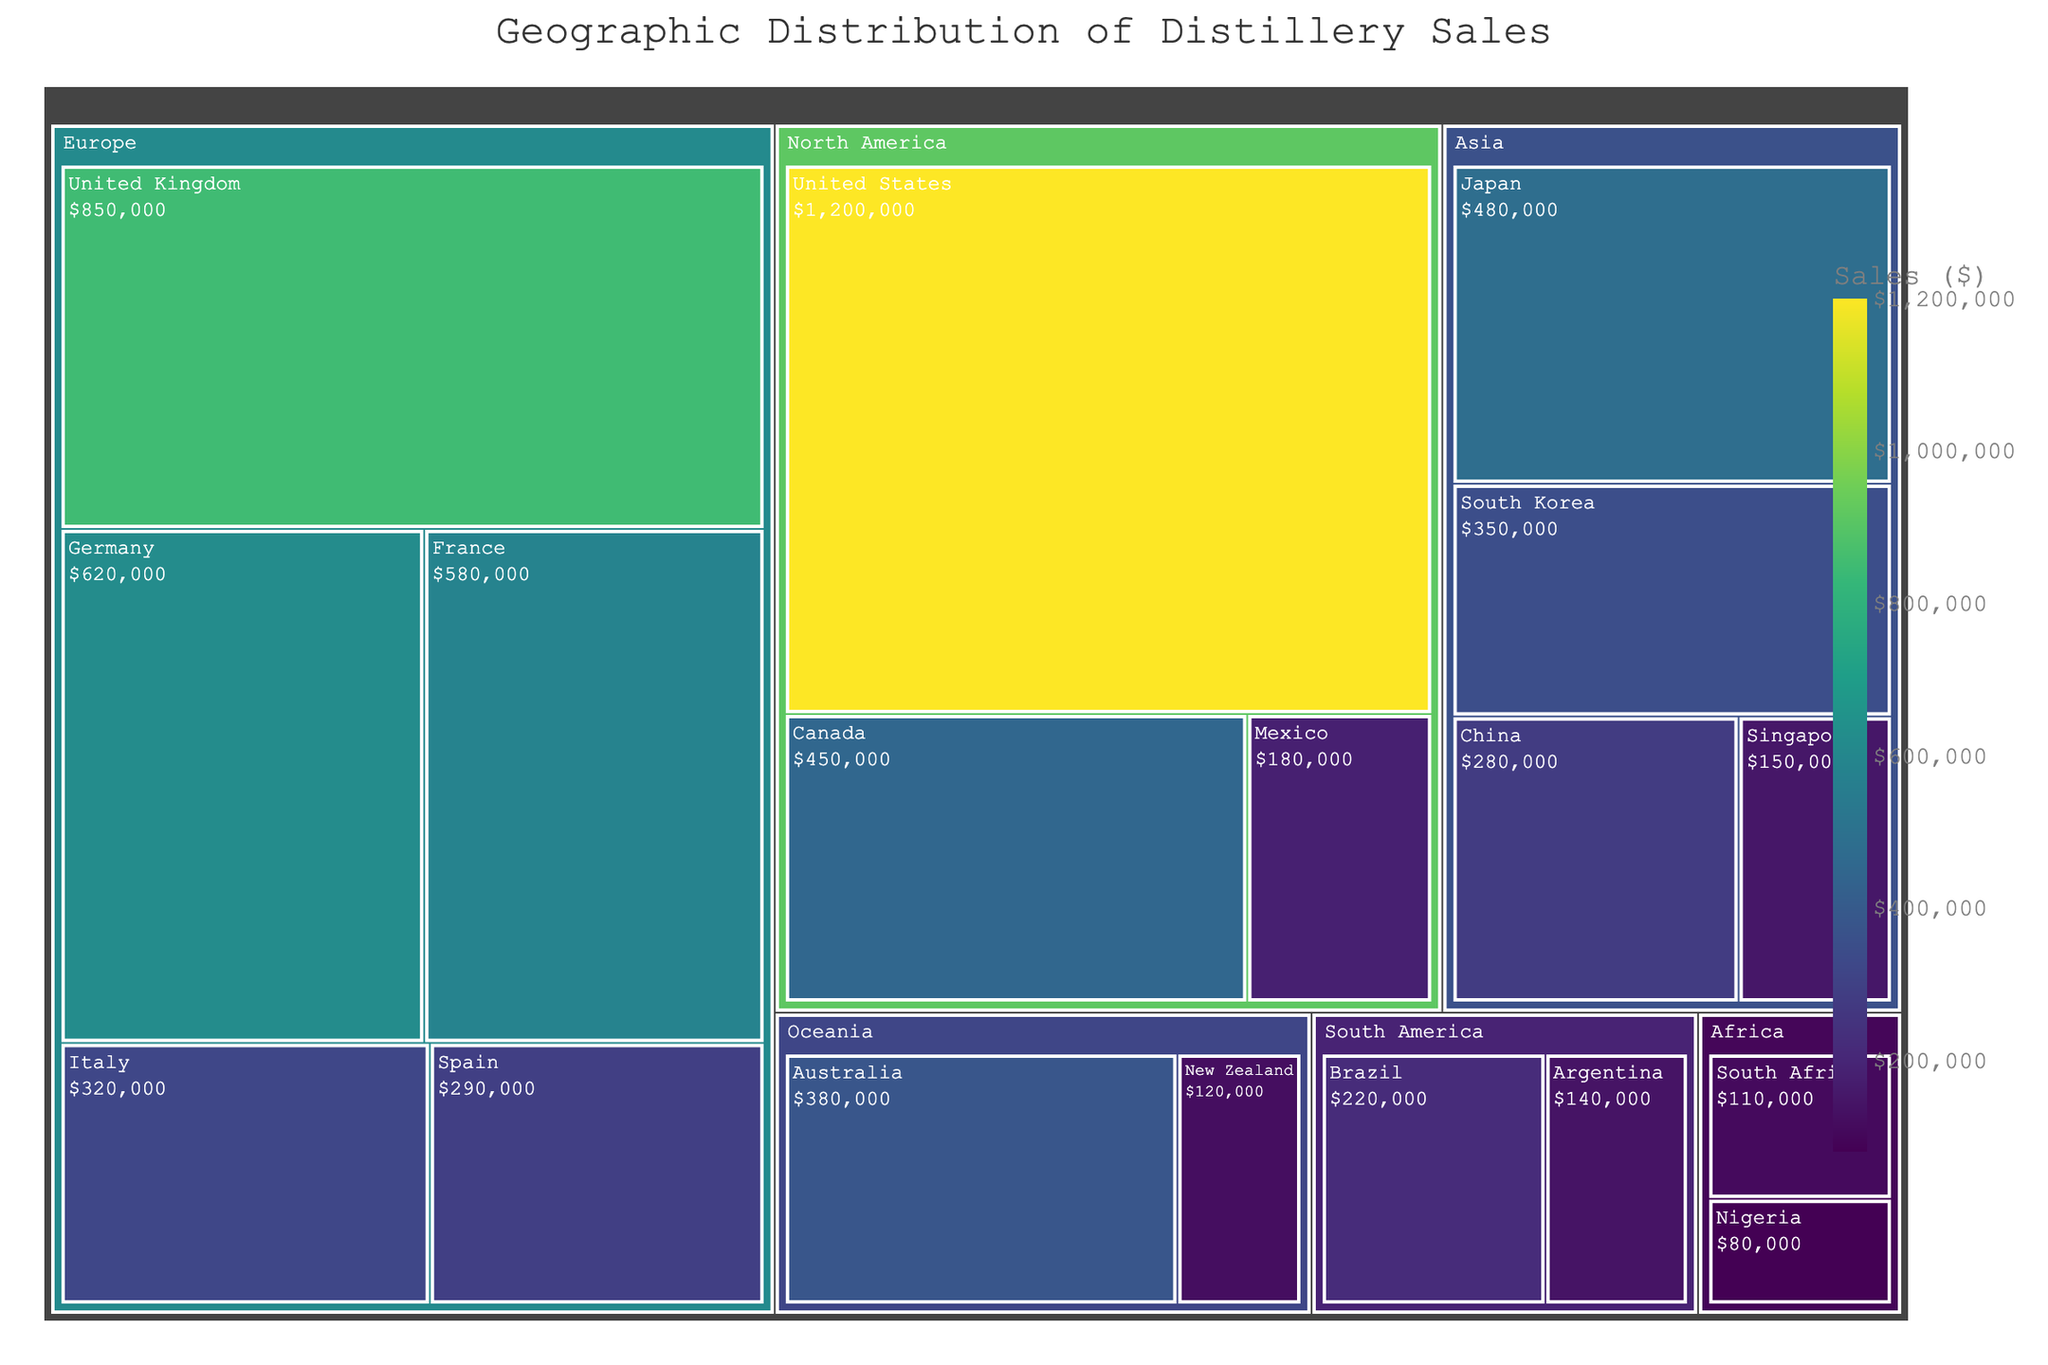What is the title of the treemap? The title of the treemap is usually found at the top of the figure and provides a concise description of what the figure represents.
Answer: Geographic Distribution of Distillery Sales Which region has the highest total sales? To determine the region with the highest total sales, add up sales values for each region and compare. The North America region has sales of $1,200,000 + $450,000 + $180,000 = $1,830,000. Europe has sales of $850,000 + $620,000 + $580,000 + $320,000 + $290,000 = $2,660,000. Asia has sales of $480,000 + $350,000 + $280,000 + $150,000 = $1,260,000. Oceania has $380,000 + $120,000 = $500,000. South America has $220,000 + $140,000 = $360,000. Africa has $110,000 + $80,000 = $190,000. Thus, Europe has the highest total sales.
Answer: Europe Which country in North America contributes the most to the region's total sales? Look at the sales values for United States, Canada, and Mexico in the North America region and identify the highest. The sales values are: United States ($1,200,000), Canada ($450,000), Mexico ($180,000). The United States has the highest sales.
Answer: United States How do the sales of Japan and South Korea compare? Compare the sales values for Japan and South Korea in the Asia region. Japan has $480,000 in sales, while South Korea has $350,000 in sales.
Answer: Japan has higher sales than South Korea What's the difference in sales between the United Kingdom and Germany? Subtract Germany's sales value from the United Kingdom's sales value. United Kingdom: $850,000; Germany: $620,000. The difference is $850,000 - $620,000 = $230,000.
Answer: $230,000 Which country in Africa has higher sales, and by how much? Compare the sales values for South Africa and Nigeria in the Africa region. South Africa has $110,000 in sales, and Nigeria has $80,000. The difference is $110,000 - $80,000 = $30,000.
Answer: South Africa by $30,000 What is the total sales for the Asia region? Add the sales values for Japan, South Korea, China, and Singapore in the Asia region. $480,000 + $350,000 + $280,000 + $150,000 = $1,260,000.
Answer: $1,260,000 Which region has the least total sales? Summing the sales values of each region and comparing them, Africa has the least sales with $110,000 (South Africa) + $80,000 (Nigeria) = $190,000.
Answer: Africa What's the approximate share of the United States in the total sales of North America? First, find the total sales for North America, which is $1,200,000 + $450,000 + $180,000 = $1,830,000. Then, compute the share of the United States: ($1,200,000 / $1,830,000) ≈ 0.656 or 65.6%.
Answer: Approximately 65.6% How does the sales of Australia compare to that of Italy? Compare the sales values of Italy ($320,000) in Europe and Australia ($380,000) in Oceania. Australia has higher sales.
Answer: Australia has higher sales 